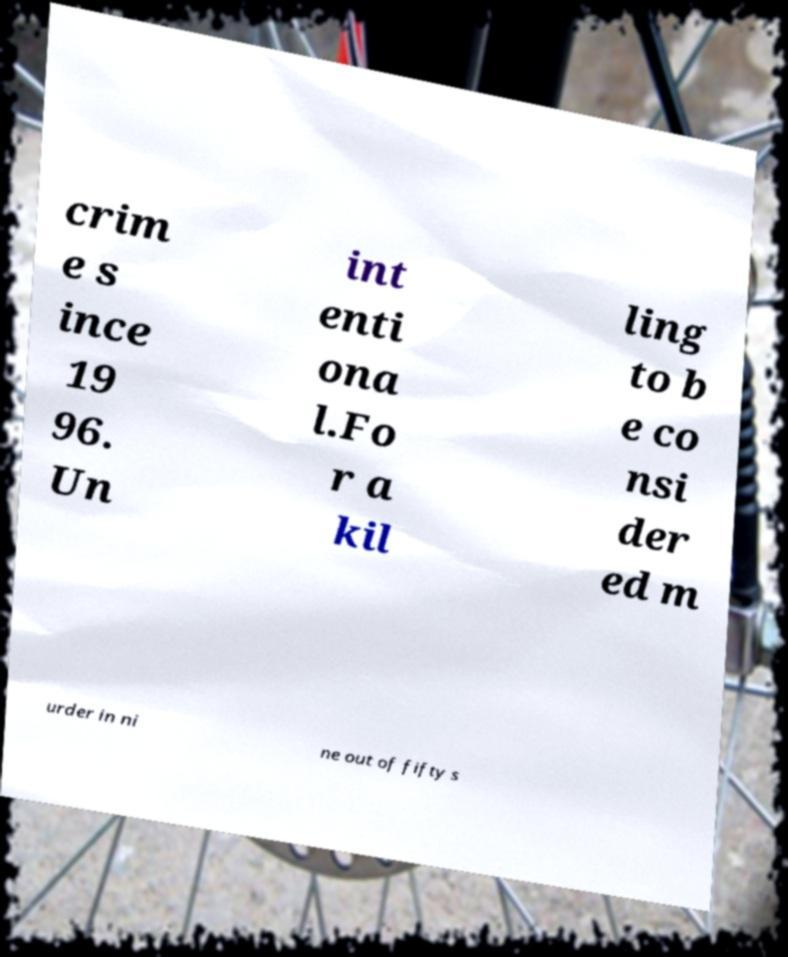Please identify and transcribe the text found in this image. crim e s ince 19 96. Un int enti ona l.Fo r a kil ling to b e co nsi der ed m urder in ni ne out of fifty s 